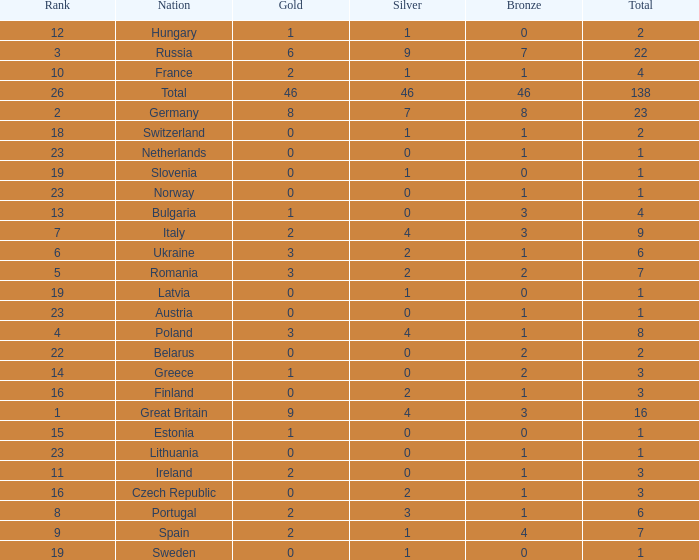What is the most bronze can be when silver is larger than 2, and the nation is germany, and gold is more than 8? None. 